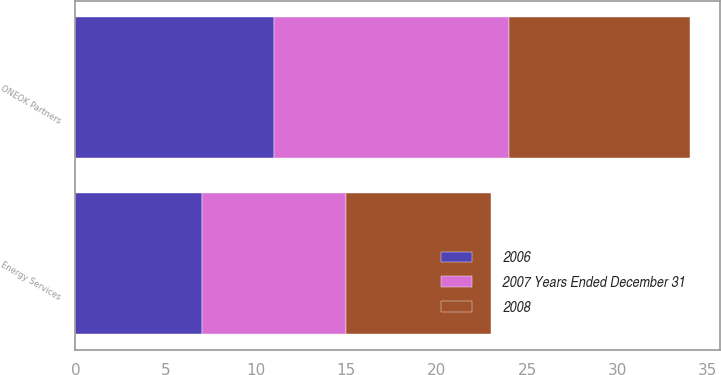Convert chart. <chart><loc_0><loc_0><loc_500><loc_500><stacked_bar_chart><ecel><fcel>ONEOK Partners<fcel>Energy Services<nl><fcel>2008<fcel>10<fcel>8<nl><fcel>2006<fcel>11<fcel>7<nl><fcel>2007 Years Ended December 31<fcel>13<fcel>8<nl></chart> 